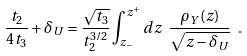<formula> <loc_0><loc_0><loc_500><loc_500>\frac { t _ { 2 } } { 4 t _ { 3 } } + \delta _ { U } = \frac { \sqrt { t _ { 3 } } } { t _ { 2 } ^ { 3 / 2 } } \int _ { z _ { - } } ^ { z ^ { + } } d z \ \frac { \rho _ { Y } ( z ) } { \sqrt { z - \delta _ { U } } } \ .</formula> 